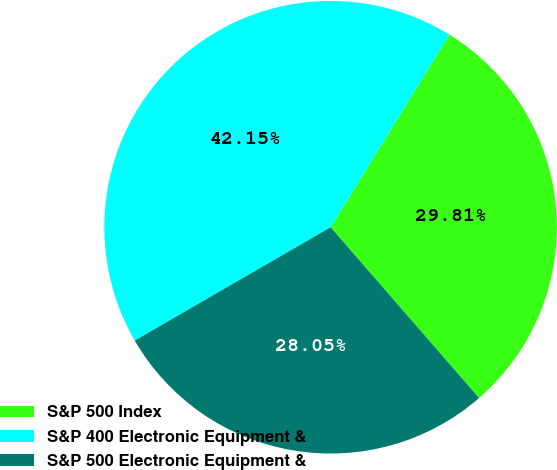Convert chart to OTSL. <chart><loc_0><loc_0><loc_500><loc_500><pie_chart><fcel>S&P 500 Index<fcel>S&P 400 Electronic Equipment &<fcel>S&P 500 Electronic Equipment &<nl><fcel>29.81%<fcel>42.15%<fcel>28.05%<nl></chart> 